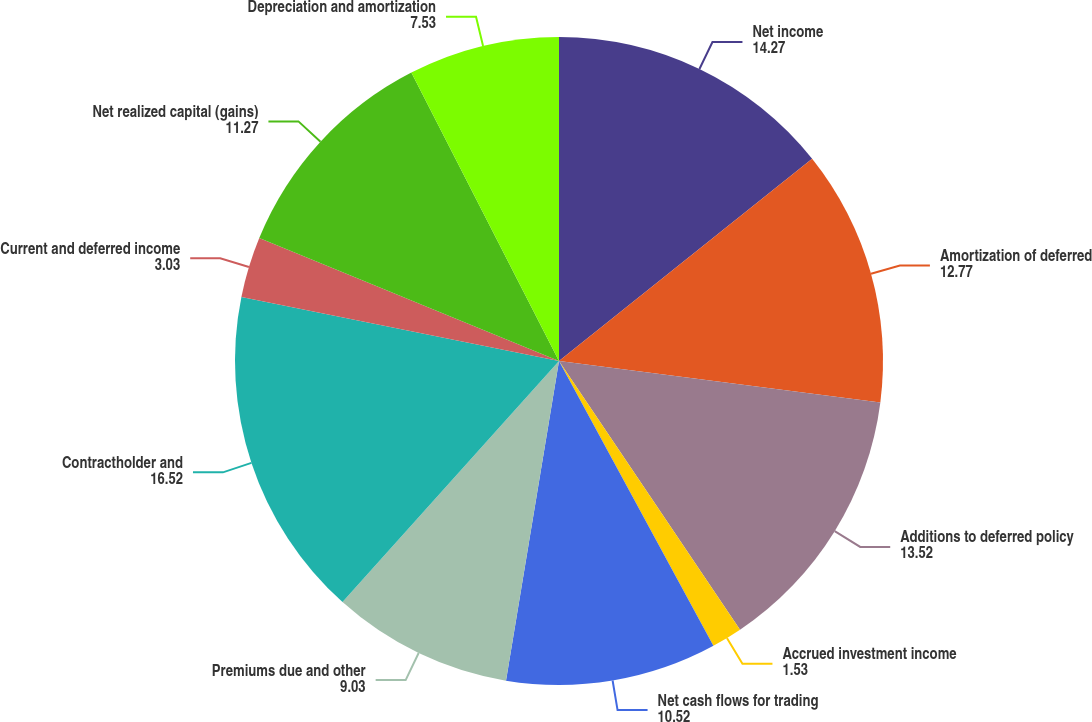<chart> <loc_0><loc_0><loc_500><loc_500><pie_chart><fcel>Net income<fcel>Amortization of deferred<fcel>Additions to deferred policy<fcel>Accrued investment income<fcel>Net cash flows for trading<fcel>Premiums due and other<fcel>Contractholder and<fcel>Current and deferred income<fcel>Net realized capital (gains)<fcel>Depreciation and amortization<nl><fcel>14.27%<fcel>12.77%<fcel>13.52%<fcel>1.53%<fcel>10.52%<fcel>9.03%<fcel>16.52%<fcel>3.03%<fcel>11.27%<fcel>7.53%<nl></chart> 